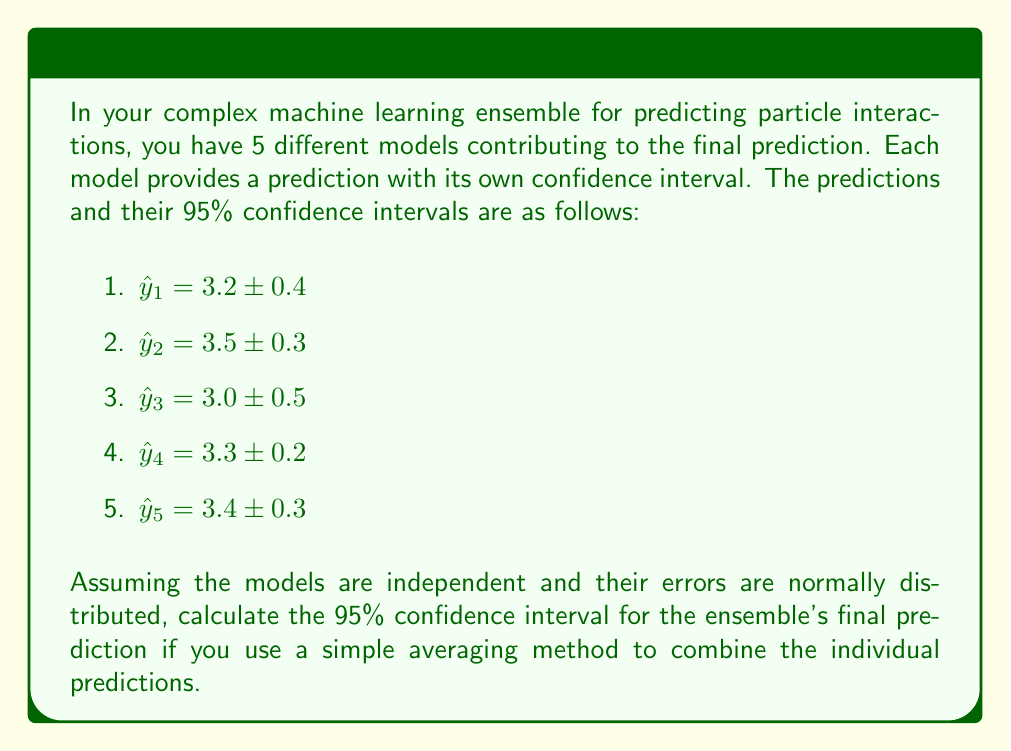What is the answer to this math problem? To solve this problem, we'll follow these steps:

1) First, we need to calculate the ensemble's final prediction by averaging the individual predictions:

   $$\hat{y}_{\text{ensemble}} = \frac{1}{5}(3.2 + 3.5 + 3.0 + 3.3 + 3.4) = 3.28$$

2) Next, we need to calculate the standard error of this ensemble prediction. Since we're assuming independence, we can use the formula for the variance of a sum of independent variables:

   $$\text{Var}(\hat{y}_{\text{ensemble}}) = \frac{1}{25}(\text{Var}(\hat{y}_1) + \text{Var}(\hat{y}_2) + \text{Var}(\hat{y}_3) + \text{Var}(\hat{y}_4) + \text{Var}(\hat{y}_5))$$

3) We can calculate each variance from the given confidence intervals. For a 95% CI, the margin of error is approximately 1.96 times the standard error. So:

   $$\text{SE}(\hat{y}_i) = \frac{\text{Margin of Error}}{1.96}$$

   $$\text{Var}(\hat{y}_i) = [\text{SE}(\hat{y}_i)]^2$$

4) Calculating for each model:

   $$\text{Var}(\hat{y}_1) = (0.4/1.96)^2 = 0.0416$$
   $$\text{Var}(\hat{y}_2) = (0.3/1.96)^2 = 0.0234$$
   $$\text{Var}(\hat{y}_3) = (0.5/1.96)^2 = 0.0650$$
   $$\text{Var}(\hat{y}_4) = (0.2/1.96)^2 = 0.0104$$
   $$\text{Var}(\hat{y}_5) = (0.3/1.96)^2 = 0.0234$$

5) Summing these and dividing by 25:

   $$\text{Var}(\hat{y}_{\text{ensemble}}) = \frac{1}{25}(0.0416 + 0.0234 + 0.0650 + 0.0104 + 0.0234) = 0.00655$$

6) The standard error of the ensemble prediction is the square root of this variance:

   $$\text{SE}(\hat{y}_{\text{ensemble}}) = \sqrt{0.00655} = 0.0809$$

7) For a 95% confidence interval, we multiply this by 1.96:

   $$\text{Margin of Error} = 1.96 * 0.0809 = 0.1586$$

8) Therefore, the 95% confidence interval for the ensemble prediction is:

   $$3.28 \pm 0.1586$$
   or
   $$[3.1214, 3.4386]$$
Answer: $3.28 \pm 0.16$ 